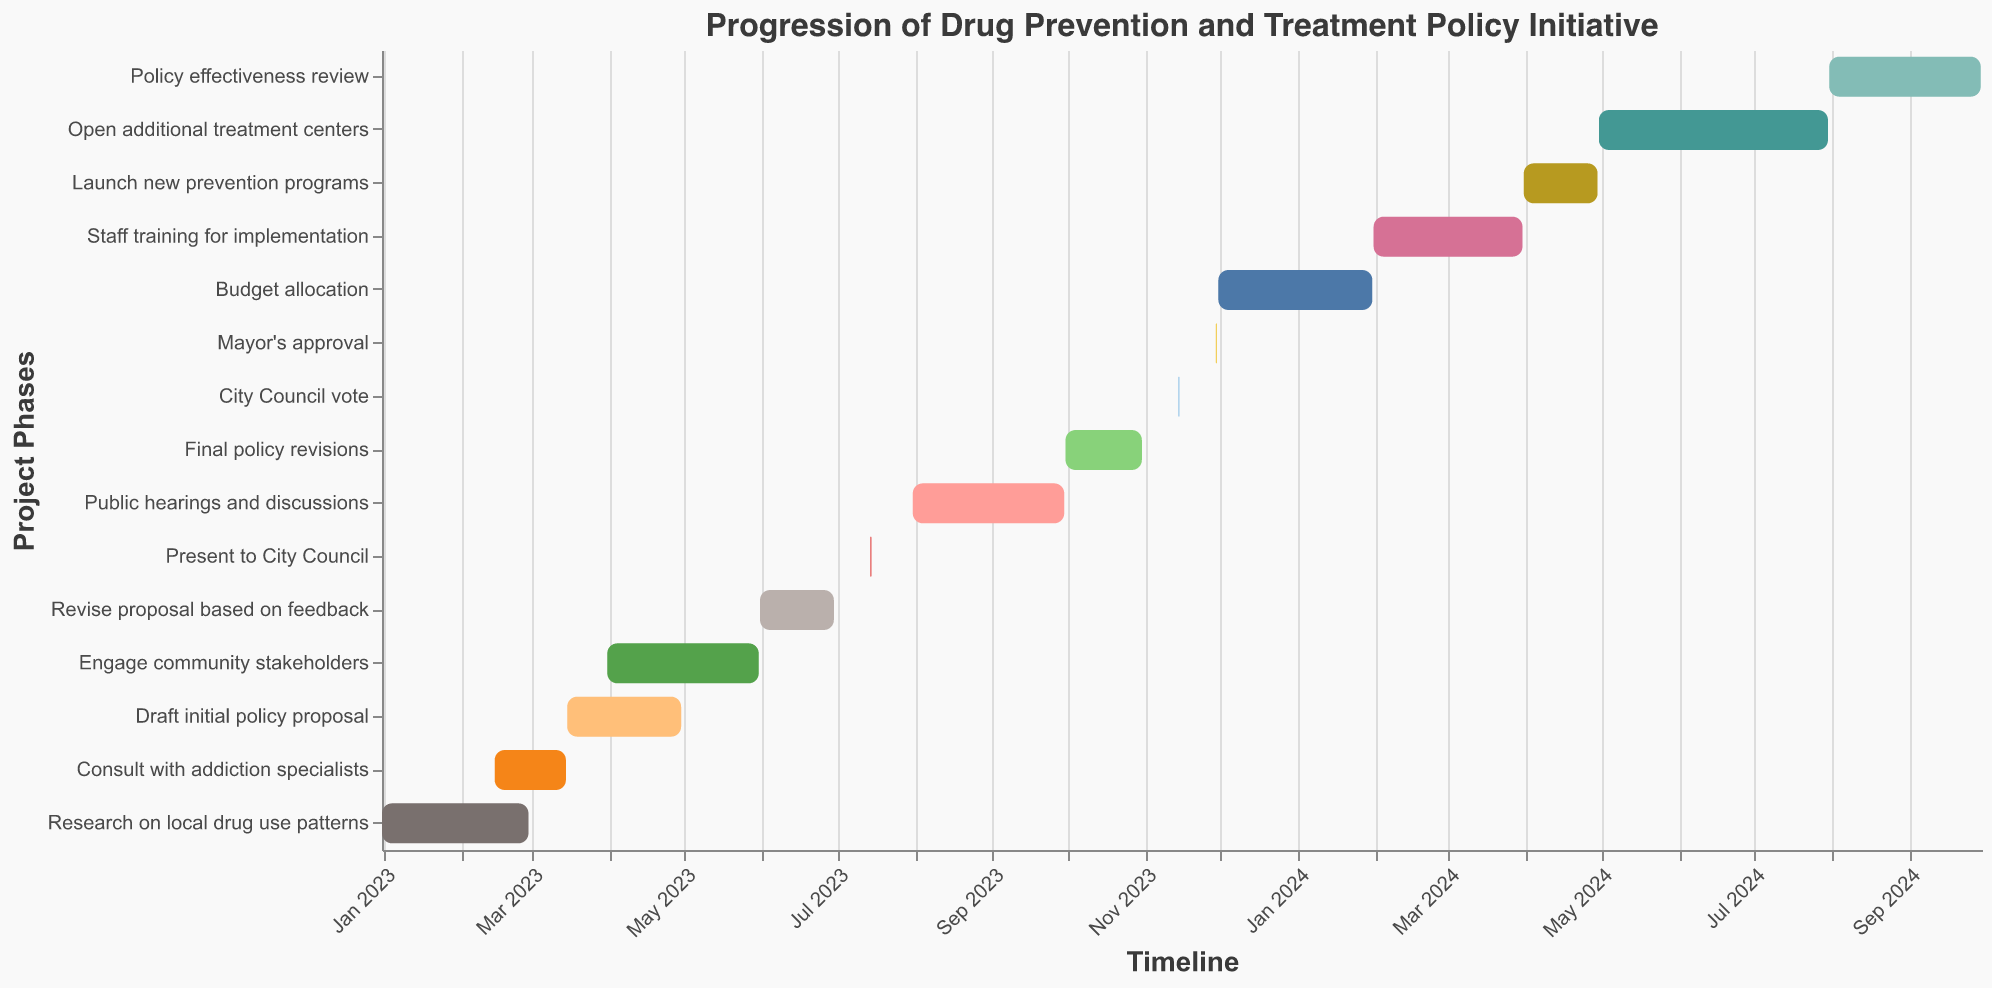What is the starting date of the "Research on local drug use patterns" task? Refer to the bar representing "Research on local drug use patterns". The left edge of the bar indicates the starting date.
Answer: January 1, 2023 When does the "Consult with addiction specialists" task end? Look at the bar labeled "Consult with addiction specialists" and identify its right endpoint, which signifies the end date.
Answer: March 15, 2023 How long is the "Draft initial policy proposal" task? Calculate the duration by identifying the start and end dates of "Draft initial policy proposal". The task starts on March 16, 2023, and ends on April 30, 2023. The difference is 45 days.
Answer: 45 days Which tasks start in April 2023? Look for bars that have their left edge falling in April 2023. "Engage community stakeholders" starts on April 1, 2023, and "Draft initial policy proposal" is ongoing in April but started in March.
Answer: Engage community stakeholders What tasks overlap with the "Engage community stakeholders" task? Identify tasks whose durations overlap with April 1, 2023, to May 31, 2023: "Draft initial policy proposal", "Revise proposal based on feedback", "Public hearings and discussions" overlap during this period.
Answer: Draft initial policy proposal, Revise proposal based on feedback, Public hearings and discussions What is the shortest task in the progression of this policy initiative? Compare the durations of all tasks by looking at the lengths of the bars. The "Present to City Council" and "City Council vote" tasks are the shortest, both being single-day tasks.
Answer: Present to City Council, City Council vote Which task has the longest duration? Find the bar with the longest span from start to end. The "Open additional treatment centers" task ranges from May 1, 2024, to July 31, 2024, making it the longest.
Answer: Open additional treatment centers How many tasks occur in 2023? Count all tasks whose bars appear within 2023. There are nine such tasks.
Answer: Nine Compare the duration of "Budget allocation" and "Staff training for implementation". Which one is longer? Calculate the durations by noting the start and end dates: "Budget allocation" is from December 1, 2023, to January 31, 2024 (62 days), and "Staff training for implementation" is from February 1, 2024, to March 31, 2024 (59 days).
Answer: Budget allocation What is the time gap between the end of "Final policy revisions" and the "City Council vote"? Determine the end date of "Final policy revisions" (October 31, 2023) and the start date of "City Council vote" (November 15, 2023). The gap is from November 1 to November 14, which is 14 days.
Answer: 14 days 